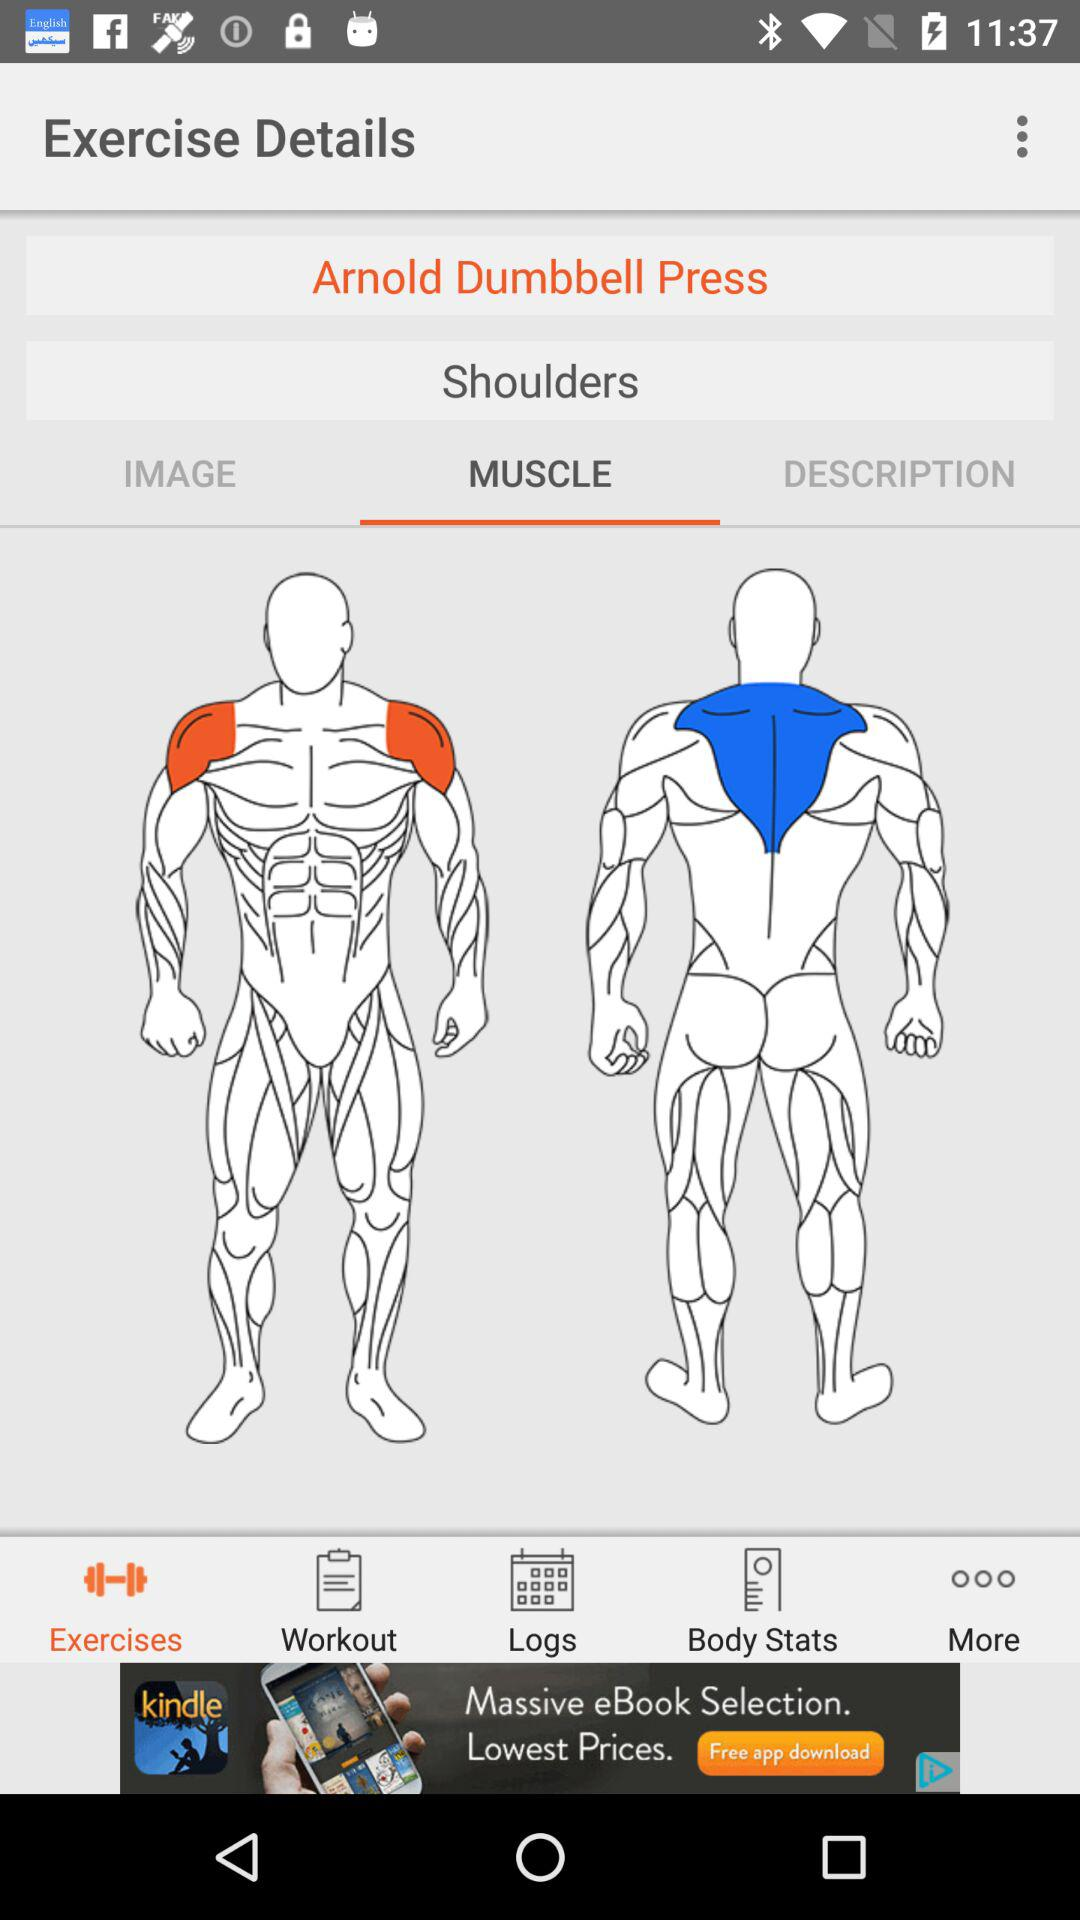Which body part is the exercise for? The exercise is for shoulders. 